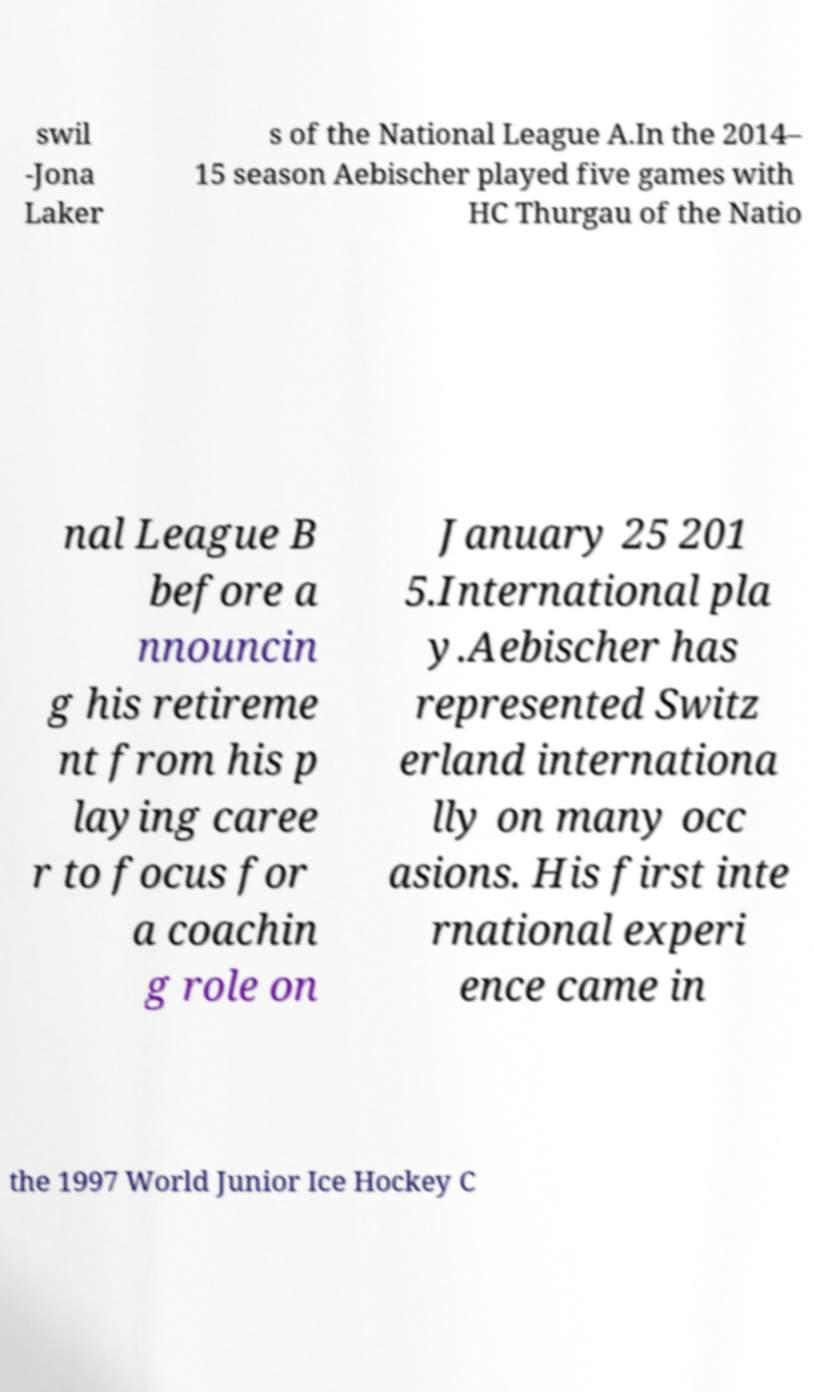Could you extract and type out the text from this image? swil -Jona Laker s of the National League A.In the 2014– 15 season Aebischer played five games with HC Thurgau of the Natio nal League B before a nnouncin g his retireme nt from his p laying caree r to focus for a coachin g role on January 25 201 5.International pla y.Aebischer has represented Switz erland internationa lly on many occ asions. His first inte rnational experi ence came in the 1997 World Junior Ice Hockey C 